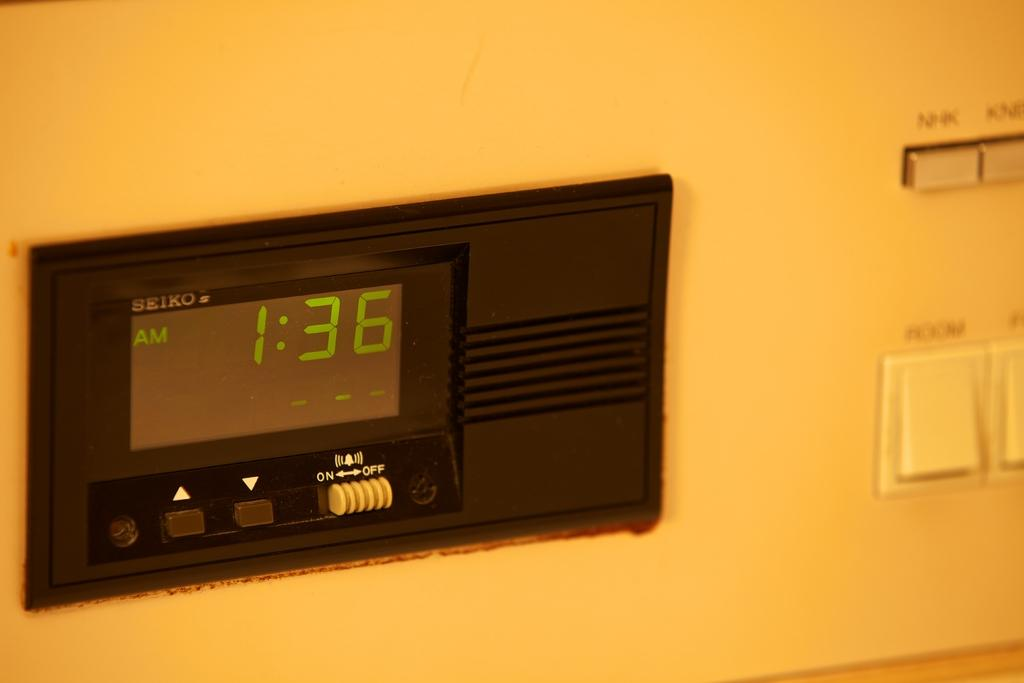Provide a one-sentence caption for the provided image. A black clock face shows the time of 1:36 AM. 